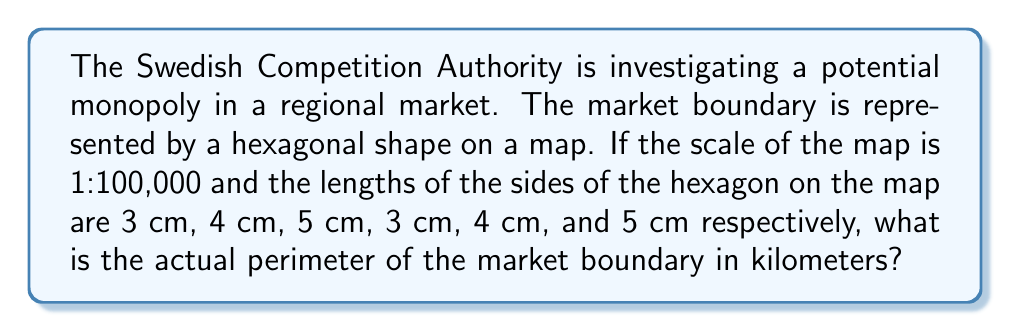What is the answer to this math problem? Let's approach this step-by-step:

1) First, we need to calculate the total length of the hexagon's perimeter on the map:
   $$3 + 4 + 5 + 3 + 4 + 5 = 24 \text{ cm}$$

2) Now, we need to convert this map distance to the actual distance using the scale:
   - The scale is 1:100,000, which means 1 cm on the map represents 100,000 cm in reality.
   - We can set up the following proportion:
     $$\frac{1 \text{ cm on map}}{100,000 \text{ cm in reality}} = \frac{24 \text{ cm on map}}{x \text{ cm in reality}}$$

3) Cross multiply:
   $$1x = 24 * 100,000$$

4) Solve for x:
   $$x = 24 * 100,000 = 2,400,000 \text{ cm}$$

5) Convert to kilometers:
   $$2,400,000 \text{ cm} = 24 \text{ km}$$

Therefore, the actual perimeter of the market boundary is 24 km.
Answer: 24 km 